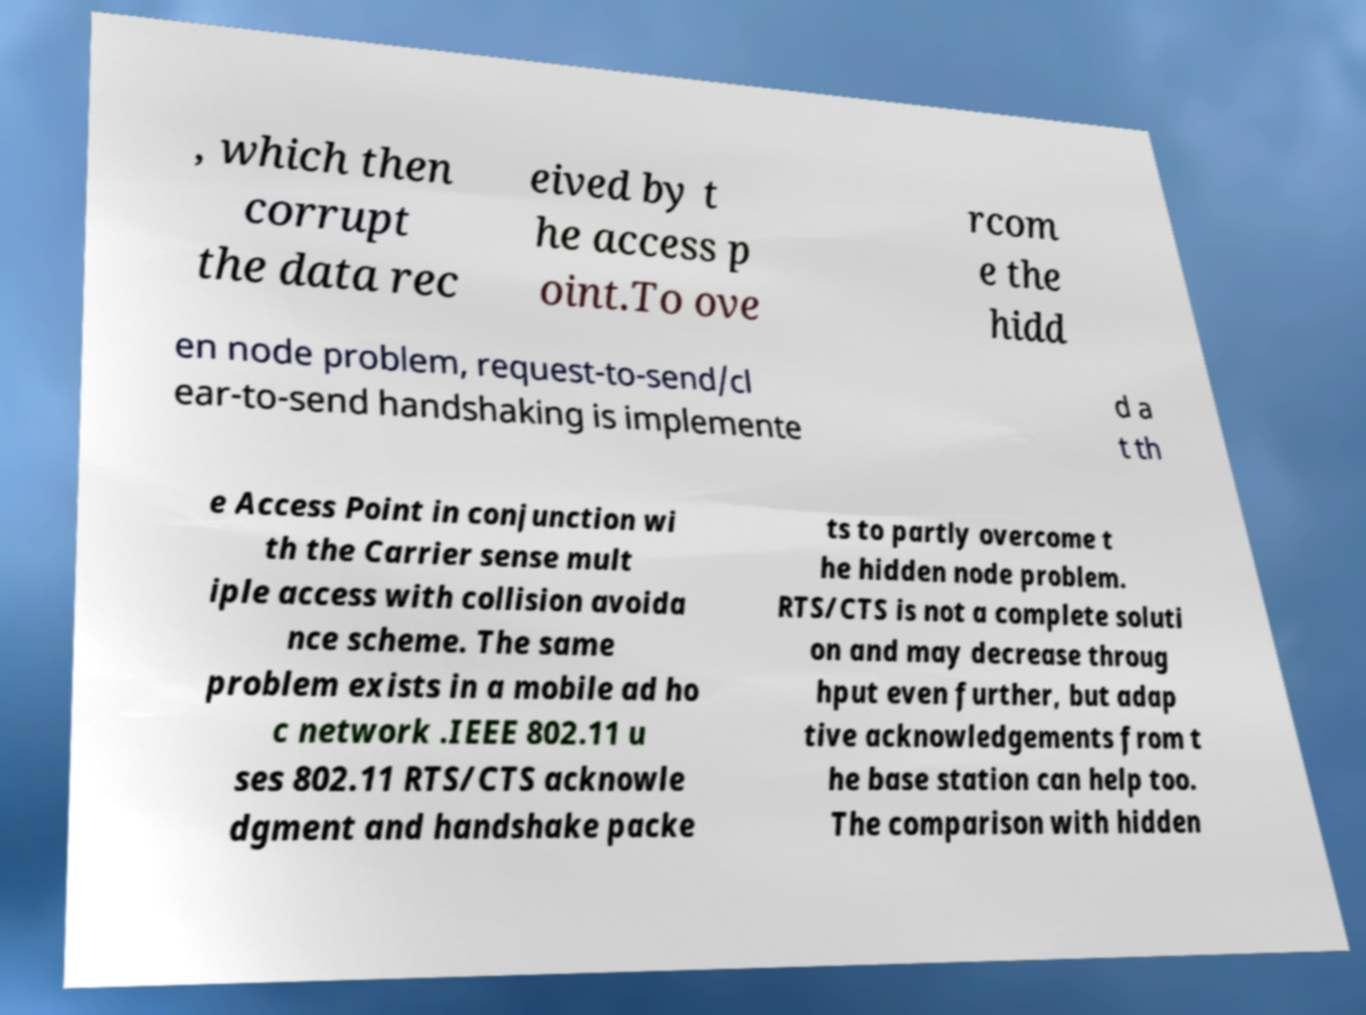Can you accurately transcribe the text from the provided image for me? , which then corrupt the data rec eived by t he access p oint.To ove rcom e the hidd en node problem, request-to-send/cl ear-to-send handshaking is implemente d a t th e Access Point in conjunction wi th the Carrier sense mult iple access with collision avoida nce scheme. The same problem exists in a mobile ad ho c network .IEEE 802.11 u ses 802.11 RTS/CTS acknowle dgment and handshake packe ts to partly overcome t he hidden node problem. RTS/CTS is not a complete soluti on and may decrease throug hput even further, but adap tive acknowledgements from t he base station can help too. The comparison with hidden 